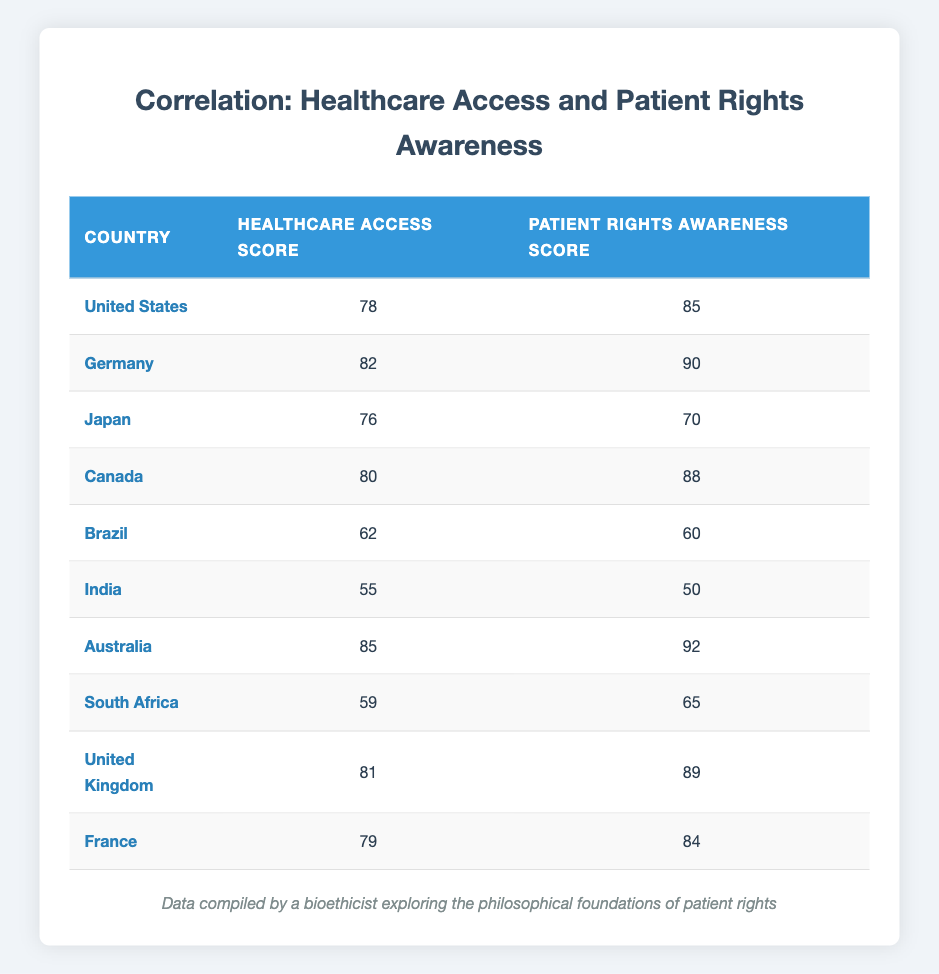What is the Healthcare Access Score for Australia? The table shows that Australia has a Healthcare Access Score of 85.
Answer: 85 Which country has the highest Patient Rights Awareness Score? By examining the Patient Rights Awareness Scores, Australia has the highest score of 92.
Answer: Australia Is the Patient Rights Awareness Score higher than the Healthcare Access Score for Japan? Japan has a Patient Rights Awareness Score of 70 and a Healthcare Access Score of 76; since 70 is lower than 76, the statement is false.
Answer: No What is the average Healthcare Access Score of all countries listed? To find the average Healthcare Access Score, add all scores (78 + 82 + 76 + 80 + 62 + 55 + 85 + 59 + 81 + 79 = 756) and divide by 10, resulting in 756 / 10 = 75.6.
Answer: 75.6 Which country has a similar Healthcare Access Score to its Patient Rights Awareness Score, and what are those scores? Brazil has a Healthcare Access Score of 62 and a Patient Rights Awareness Score of 60; the difference is minimal, indicating a close relationship between both scores.
Answer: Brazil: 62, 60 Is the statement true or false: Canada has a lower Patient Rights Awareness Score than Germany? Canada has a Patient Rights Awareness Score of 88 while Germany's is 90; since 88 is lower than 90, the statement is false.
Answer: False What is the difference between the highest and lowest Healthcare Access Scores? The highest score is 85 (Australia) and the lowest is 55 (India), so the difference is 85 - 55 = 30.
Answer: 30 Are there any countries where the Patient Rights Awareness Score is not above 70? Checking the scores, India (50), Brazil (60), and South Africa (65) have Patient Rights Awareness Scores below 70, confirming that the statement is true.
Answer: Yes What is the total Patient Rights Awareness Score of all countries? Adding all Patient Rights Awareness Scores together (85 + 90 + 70 + 88 + 60 + 50 + 92 + 65 + 89 + 84 = 819), gives a total of 819.
Answer: 819 Which country has the closest values between Healthcare Access Score and Patient Rights Awareness Score? By examining the differences, Brazil has scores of 62 and 60, giving a difference of only 2; hence, it has the closest values.
Answer: Brazil: 62, 60 